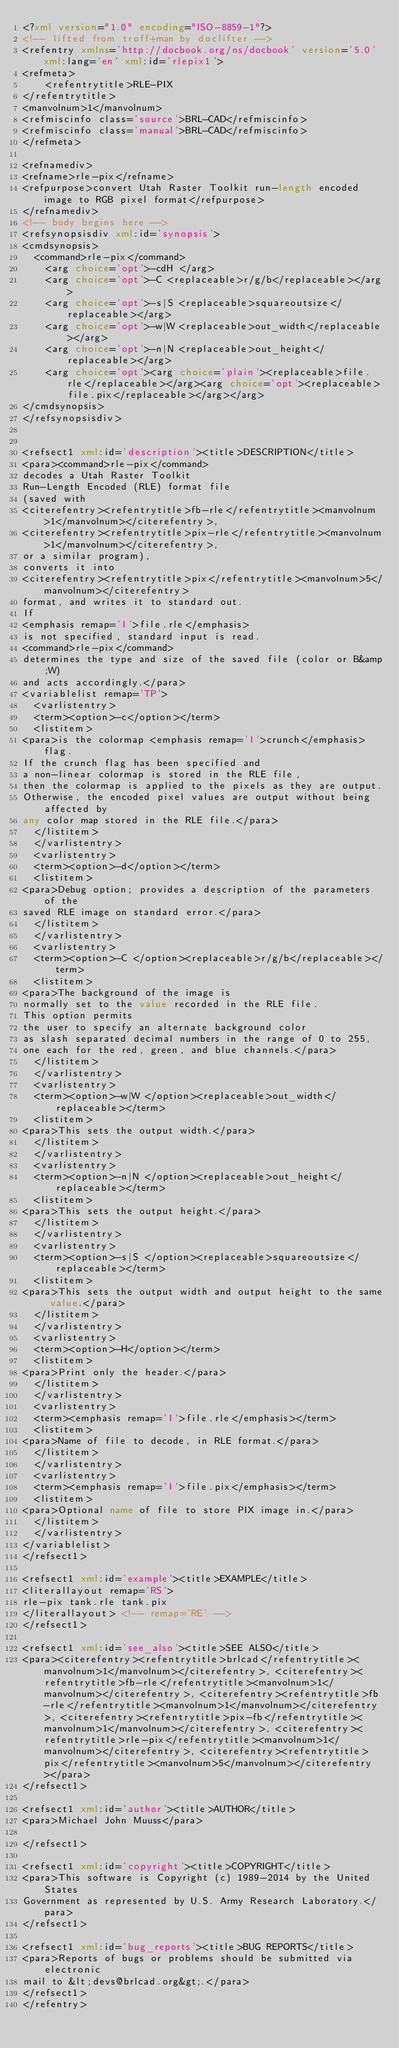<code> <loc_0><loc_0><loc_500><loc_500><_XML_><?xml version="1.0" encoding="ISO-8859-1"?>
<!-- lifted from troff+man by doclifter -->
<refentry xmlns='http://docbook.org/ns/docbook' version='5.0' xml:lang='en' xml:id='rlepix1'>
<refmeta>
    <refentrytitle>RLE-PIX
</refentrytitle>
<manvolnum>1</manvolnum>
<refmiscinfo class='source'>BRL-CAD</refmiscinfo>
<refmiscinfo class='manual'>BRL-CAD</refmiscinfo>
</refmeta>

<refnamediv>
<refname>rle-pix</refname>
<refpurpose>convert Utah Raster Toolkit run-length encoded image to RGB pixel format</refpurpose>
</refnamediv>
<!-- body begins here -->
<refsynopsisdiv xml:id='synopsis'>
<cmdsynopsis>
  <command>rle-pix</command>
    <arg choice='opt'>-cdH </arg>
    <arg choice='opt'>-C <replaceable>r/g/b</replaceable></arg>
    <arg choice='opt'>-s|S <replaceable>squareoutsize</replaceable></arg>
    <arg choice='opt'>-w|W <replaceable>out_width</replaceable></arg>
    <arg choice='opt'>-n|N <replaceable>out_height</replaceable></arg>
    <arg choice='opt'><arg choice='plain'><replaceable>file.rle</replaceable></arg><arg choice='opt'><replaceable>file.pix</replaceable></arg></arg>
</cmdsynopsis>
</refsynopsisdiv>


<refsect1 xml:id='description'><title>DESCRIPTION</title>
<para><command>rle-pix</command>
decodes a Utah Raster Toolkit
Run-Length Encoded (RLE) format file
(saved with
<citerefentry><refentrytitle>fb-rle</refentrytitle><manvolnum>1</manvolnum></citerefentry>,
<citerefentry><refentrytitle>pix-rle</refentrytitle><manvolnum>1</manvolnum></citerefentry>,
or a similar program),
converts it into
<citerefentry><refentrytitle>pix</refentrytitle><manvolnum>5</manvolnum></citerefentry>
format, and writes it to standard out.
If
<emphasis remap='I'>file.rle</emphasis>
is not specified, standard input is read.
<command>rle-pix</command>
determines the type and size of the saved file (color or B&amp;W)
and acts accordingly.</para>
<variablelist remap='TP'>
  <varlistentry>
  <term><option>-c</option></term>
  <listitem>
<para>is the colormap <emphasis remap='I'>crunch</emphasis> flag.
If the crunch flag has been specified and
a non-linear colormap is stored in the RLE file,
then the colormap is applied to the pixels as they are output.
Otherwise, the encoded pixel values are output without being affected by
any color map stored in the RLE file.</para>
  </listitem>
  </varlistentry>
  <varlistentry>
  <term><option>-d</option></term>
  <listitem>
<para>Debug option; provides a description of the parameters of the
saved RLE image on standard error.</para>
  </listitem>
  </varlistentry>
  <varlistentry>
  <term><option>-C </option><replaceable>r/g/b</replaceable></term>
  <listitem>
<para>The background of the image is
normally set to the value recorded in the RLE file.
This option permits
the user to specify an alternate background color
as slash separated decimal numbers in the range of 0 to 255,
one each for the red, green, and blue channels.</para>
  </listitem>
  </varlistentry>
  <varlistentry>
  <term><option>-w|W </option><replaceable>out_width</replaceable></term>
  <listitem>
<para>This sets the output width.</para>
  </listitem>
  </varlistentry>
  <varlistentry>
  <term><option>-n|N </option><replaceable>out_height</replaceable></term>
  <listitem>
<para>This sets the output height.</para>
  </listitem>
  </varlistentry>
  <varlistentry>
  <term><option>-s|S </option><replaceable>squareoutsize</replaceable></term>
  <listitem>
<para>This sets the output width and output height to the same value.</para>
  </listitem>
  </varlistentry>
  <varlistentry>
  <term><option>-H</option></term>
  <listitem>
<para>Print only the header.</para>
  </listitem>
  </varlistentry>
  <varlistentry>
  <term><emphasis remap='I'>file.rle</emphasis></term>
  <listitem>
<para>Name of file to decode, in RLE format.</para>
  </listitem>
  </varlistentry>
  <varlistentry>
  <term><emphasis remap='I'>file.pix</emphasis></term>
  <listitem>
<para>Optional name of file to store PIX image in.</para>
  </listitem>
  </varlistentry>
</variablelist>
</refsect1>

<refsect1 xml:id='example'><title>EXAMPLE</title>
<literallayout remap='RS'>
rle-pix tank.rle tank.pix
</literallayout> <!-- remap='RE' -->
</refsect1>

<refsect1 xml:id='see_also'><title>SEE ALSO</title>
<para><citerefentry><refentrytitle>brlcad</refentrytitle><manvolnum>1</manvolnum></citerefentry>, <citerefentry><refentrytitle>fb-rle</refentrytitle><manvolnum>1</manvolnum></citerefentry>, <citerefentry><refentrytitle>fb-rle</refentrytitle><manvolnum>1</manvolnum></citerefentry>, <citerefentry><refentrytitle>pix-fb</refentrytitle><manvolnum>1</manvolnum></citerefentry>, <citerefentry><refentrytitle>rle-pix</refentrytitle><manvolnum>1</manvolnum></citerefentry>, <citerefentry><refentrytitle>pix</refentrytitle><manvolnum>5</manvolnum></citerefentry></para>
</refsect1>

<refsect1 xml:id='author'><title>AUTHOR</title>
<para>Michael John Muuss</para>

</refsect1>

<refsect1 xml:id='copyright'><title>COPYRIGHT</title>
<para>This software is Copyright (c) 1989-2014 by the United States
Government as represented by U.S. Army Research Laboratory.</para>
</refsect1>

<refsect1 xml:id='bug_reports'><title>BUG REPORTS</title>
<para>Reports of bugs or problems should be submitted via electronic
mail to &lt;devs@brlcad.org&gt;.</para>
</refsect1>
</refentry>

</code> 